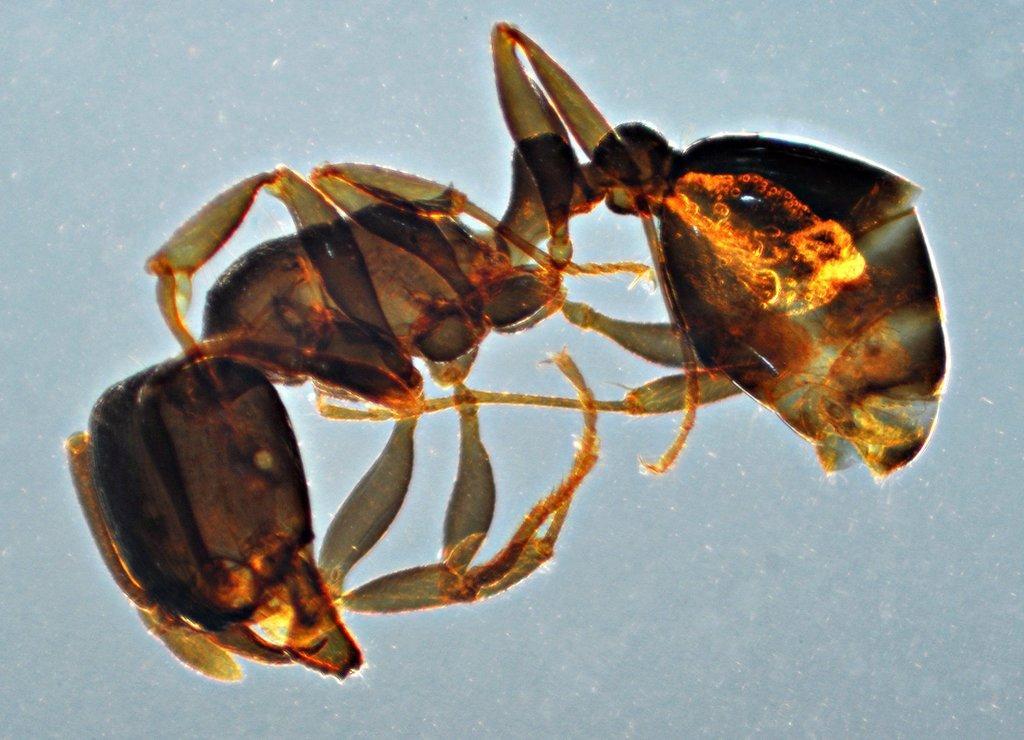Please provide a concise description of this image. In this image I can see an insect. The background is white in color. 